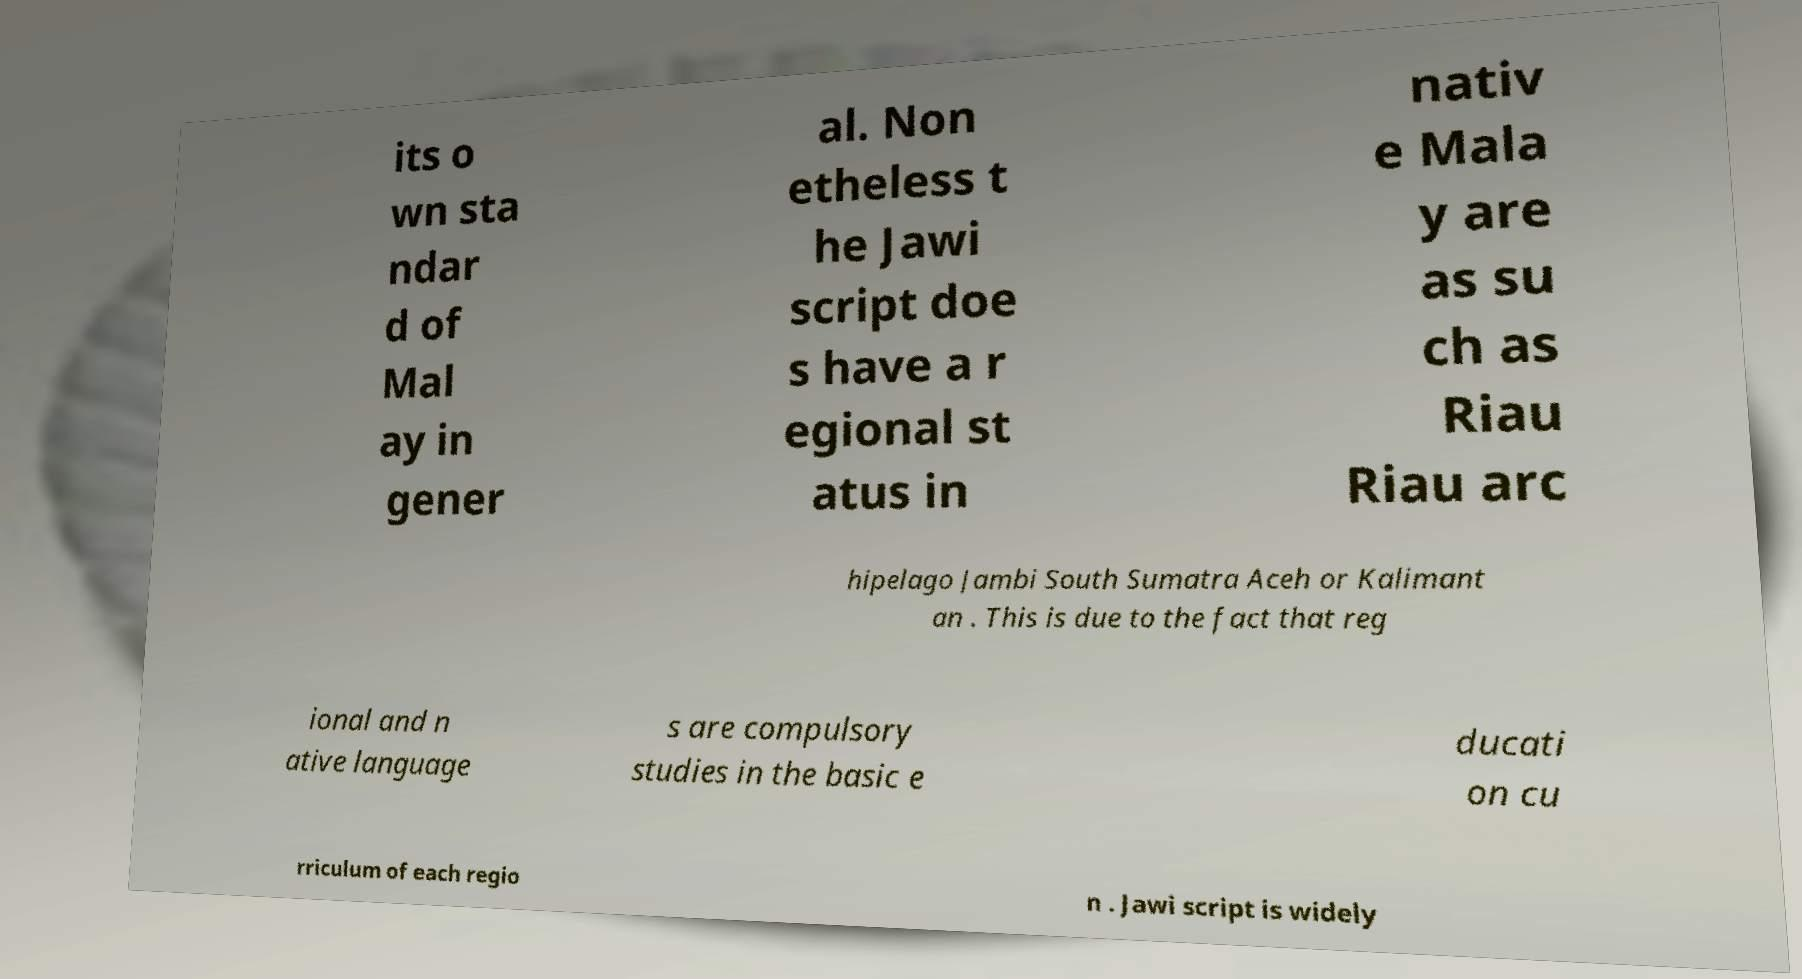Could you extract and type out the text from this image? its o wn sta ndar d of Mal ay in gener al. Non etheless t he Jawi script doe s have a r egional st atus in nativ e Mala y are as su ch as Riau Riau arc hipelago Jambi South Sumatra Aceh or Kalimant an . This is due to the fact that reg ional and n ative language s are compulsory studies in the basic e ducati on cu rriculum of each regio n . Jawi script is widely 